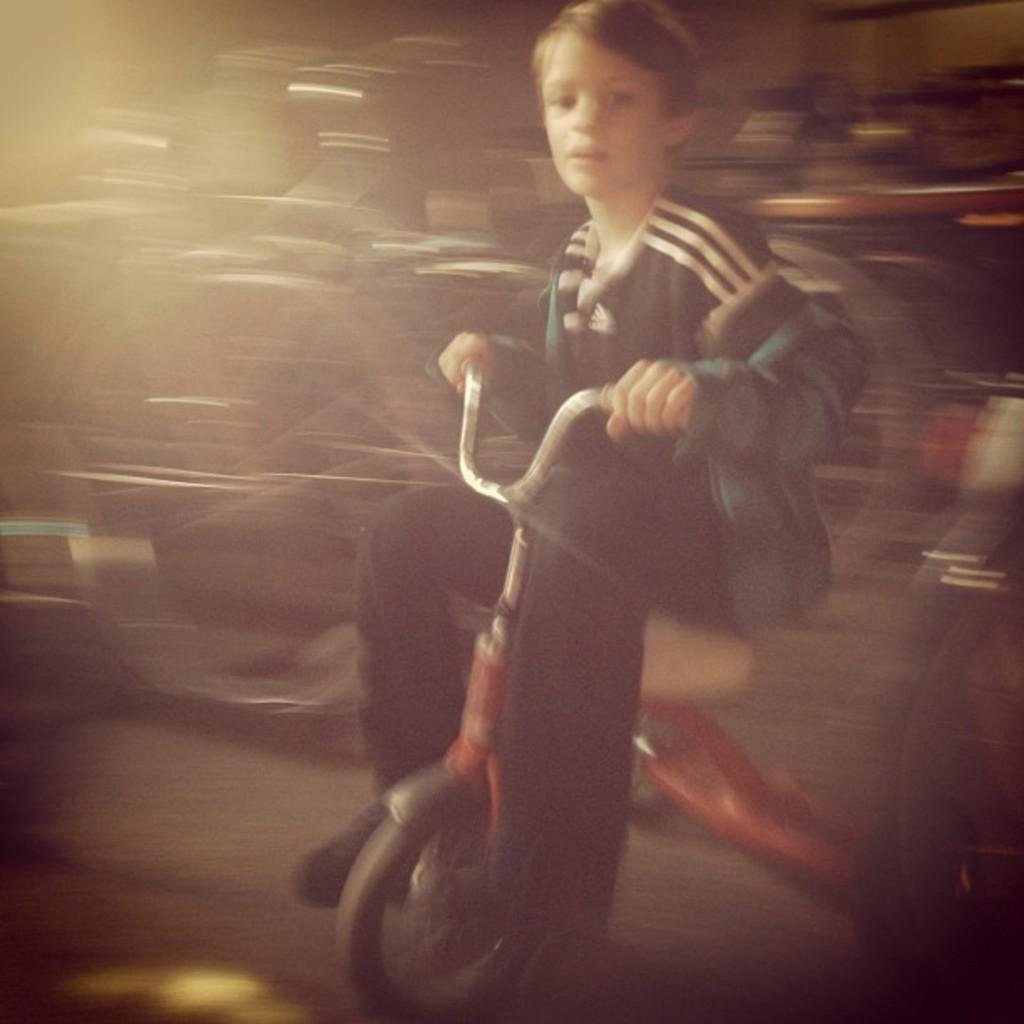What is the main subject of the image? The main subject of the image is a kid. What is the kid wearing in the image? The kid is wearing a black dress in the image. What activity is the kid engaged in? The kid is riding a bicycle in the image. What type of plants can be seen growing in the quiet area of the image? There are no plants or quiet areas mentioned in the image; it features a kid riding a bicycle. 